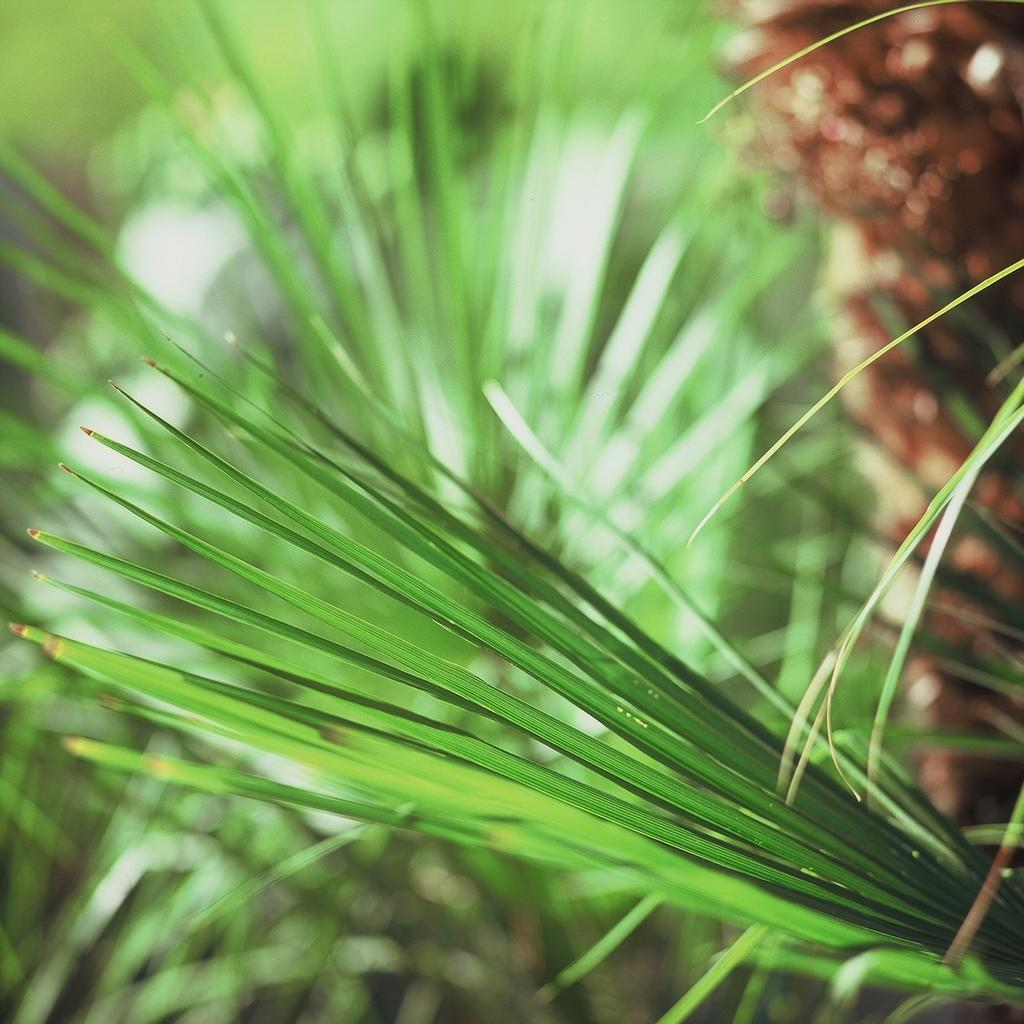What type of vegetation is present in the image? There are green leaves in the image. Can you describe the object on the right side of the image? There is a brown object on the right side of the image. How many spiders are crawling on the jellyfish in the image? There are no spiders or jellyfish present in the image. 